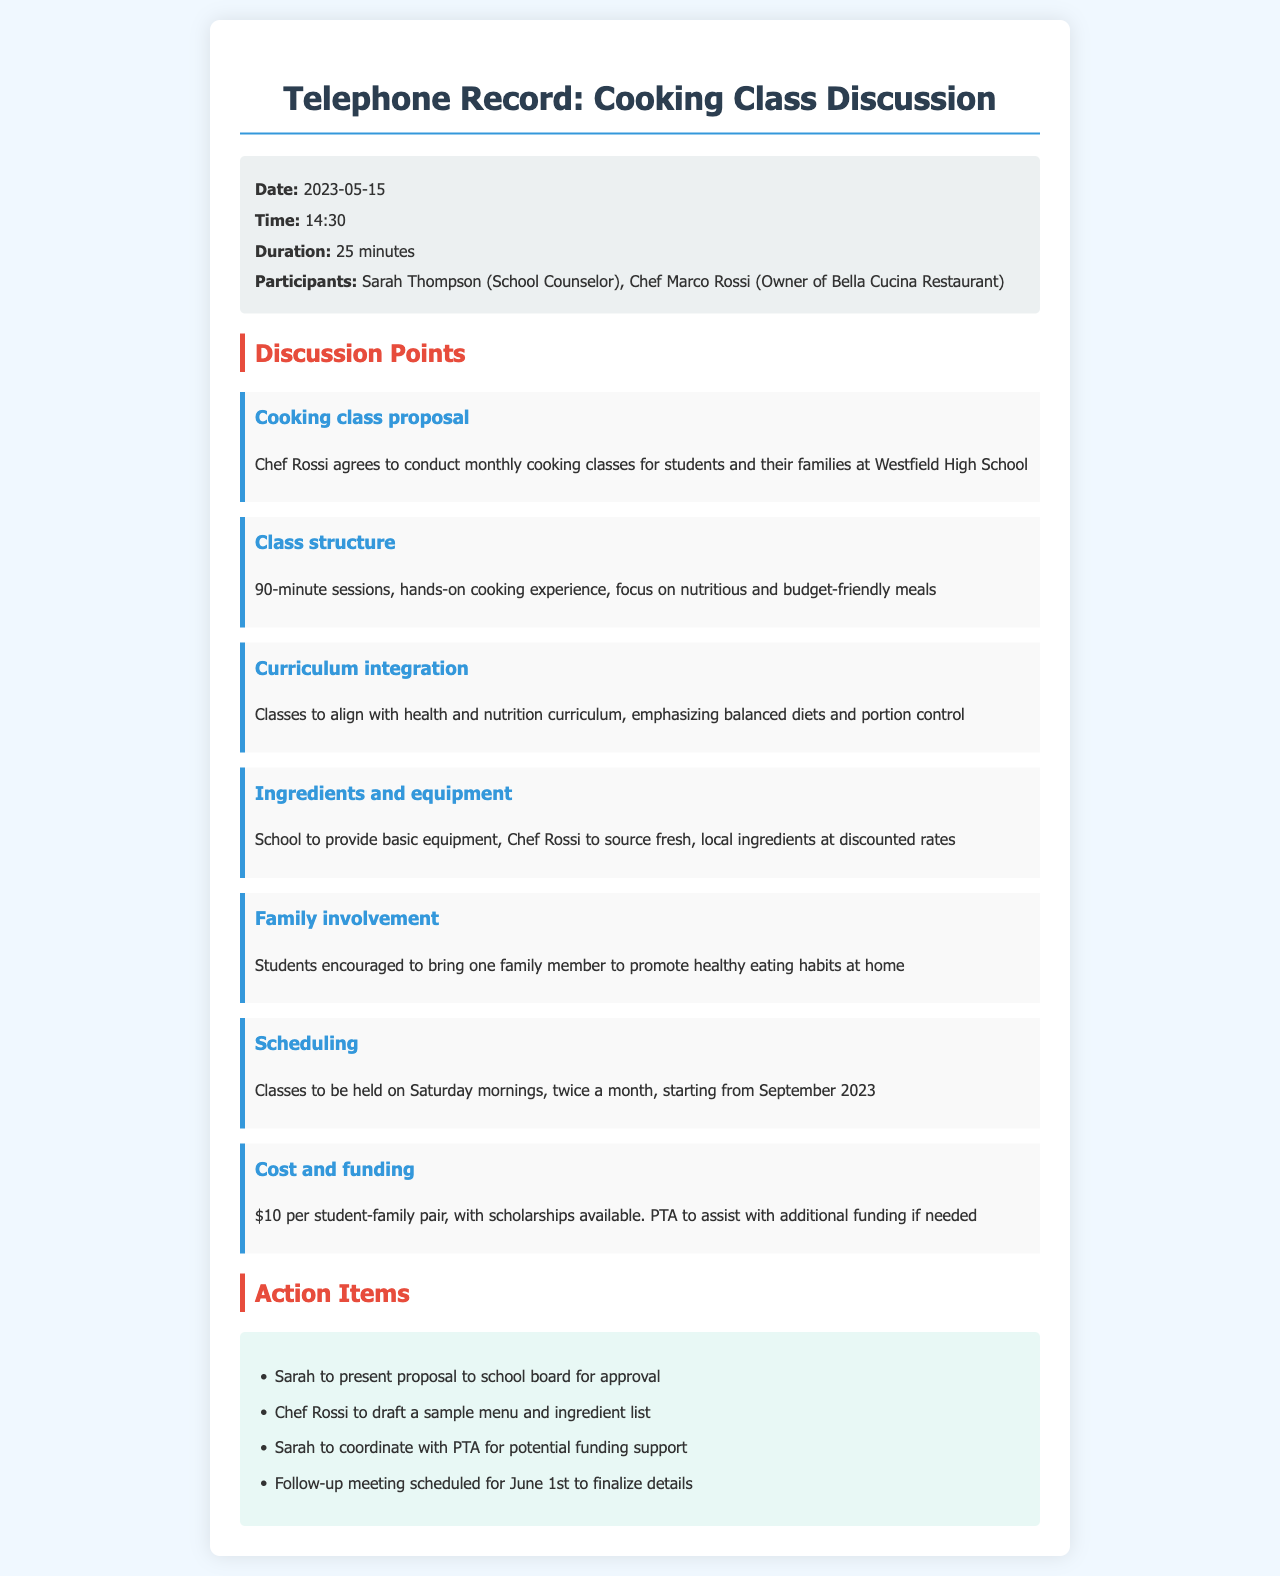What is the date of the call? The call took place on May 15, 2023, as stated in the call details section.
Answer: May 15, 2023 Who conducted the classes? The classes will be conducted by Chef Marco Rossi, as mentioned in the discussion points.
Answer: Chef Marco Rossi How long will each cooking class session last? Each session is stated to be 90 minutes long in the class structure discussion point.
Answer: 90 minutes When will the classes start? The classes are scheduled to start in September 2023, according to the scheduling section.
Answer: September 2023 What is the cost per student-family pair? The cost is mentioned to be $10 per student-family pair in the cost and funding discussion point.
Answer: $10 What is the focus of the cooking classes? The focus of the classes is on nutritious and budget-friendly meals, as indicated in the class structure.
Answer: Nutritious and budget-friendly meals How often will the cooking classes be held? The document states that classes will be held twice a month, reflected in the scheduling section.
Answer: Twice a month What will Sarah Thompson present to the school board? Sarah is tasked with presenting the proposal to the school board, which is mentioned in the action items.
Answer: Proposal What is an action item for Chef Rossi? Chef Rossi is to draft a sample menu and ingredient list, as listed in the action items.
Answer: Draft a sample menu and ingredient list 